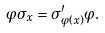<formula> <loc_0><loc_0><loc_500><loc_500>\varphi \sigma _ { x } = \sigma ^ { \prime } _ { \varphi ( x ) } \varphi .</formula> 